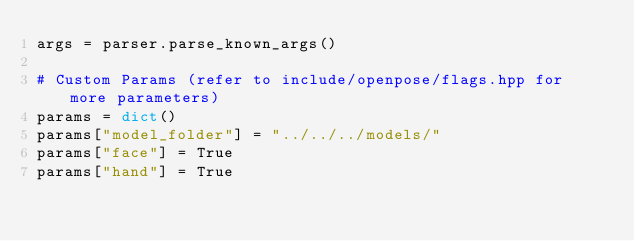Convert code to text. <code><loc_0><loc_0><loc_500><loc_500><_Python_>args = parser.parse_known_args()

# Custom Params (refer to include/openpose/flags.hpp for more parameters)
params = dict()
params["model_folder"] = "../../../models/"
params["face"] = True
params["hand"] = True
</code> 